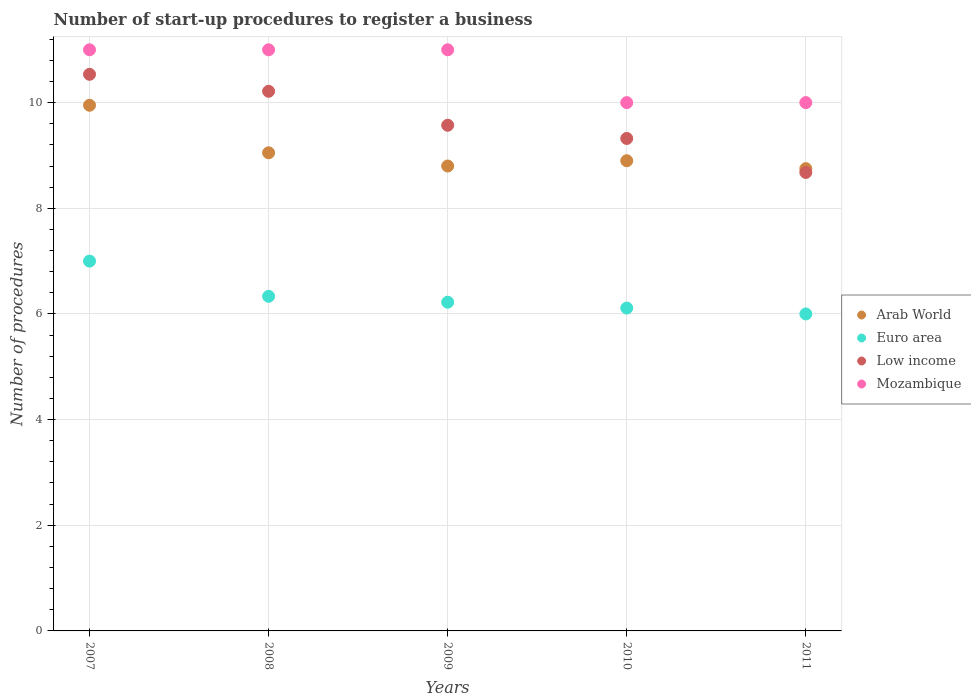How many different coloured dotlines are there?
Keep it short and to the point. 4. Is the number of dotlines equal to the number of legend labels?
Ensure brevity in your answer.  Yes. What is the number of procedures required to register a business in Arab World in 2010?
Make the answer very short. 8.9. Across all years, what is the maximum number of procedures required to register a business in Euro area?
Your response must be concise. 7. Across all years, what is the minimum number of procedures required to register a business in Mozambique?
Offer a terse response. 10. What is the total number of procedures required to register a business in Euro area in the graph?
Ensure brevity in your answer.  31.67. What is the difference between the number of procedures required to register a business in Low income in 2010 and that in 2011?
Keep it short and to the point. 0.64. What is the difference between the number of procedures required to register a business in Mozambique in 2011 and the number of procedures required to register a business in Low income in 2007?
Keep it short and to the point. -0.54. What is the average number of procedures required to register a business in Euro area per year?
Give a very brief answer. 6.33. In the year 2009, what is the difference between the number of procedures required to register a business in Arab World and number of procedures required to register a business in Low income?
Offer a terse response. -0.77. In how many years, is the number of procedures required to register a business in Low income greater than 10.4?
Your answer should be compact. 1. What is the ratio of the number of procedures required to register a business in Euro area in 2010 to that in 2011?
Ensure brevity in your answer.  1.02. What is the difference between the highest and the lowest number of procedures required to register a business in Mozambique?
Provide a short and direct response. 1. In how many years, is the number of procedures required to register a business in Euro area greater than the average number of procedures required to register a business in Euro area taken over all years?
Your answer should be very brief. 1. Is the sum of the number of procedures required to register a business in Euro area in 2007 and 2008 greater than the maximum number of procedures required to register a business in Arab World across all years?
Your answer should be very brief. Yes. Is it the case that in every year, the sum of the number of procedures required to register a business in Mozambique and number of procedures required to register a business in Low income  is greater than the number of procedures required to register a business in Euro area?
Keep it short and to the point. Yes. Is the number of procedures required to register a business in Arab World strictly greater than the number of procedures required to register a business in Euro area over the years?
Provide a succinct answer. Yes. How many dotlines are there?
Make the answer very short. 4. How many years are there in the graph?
Your answer should be compact. 5. Are the values on the major ticks of Y-axis written in scientific E-notation?
Provide a succinct answer. No. Does the graph contain any zero values?
Provide a succinct answer. No. Does the graph contain grids?
Keep it short and to the point. Yes. Where does the legend appear in the graph?
Make the answer very short. Center right. How many legend labels are there?
Provide a succinct answer. 4. What is the title of the graph?
Provide a short and direct response. Number of start-up procedures to register a business. What is the label or title of the Y-axis?
Your answer should be compact. Number of procedures. What is the Number of procedures in Arab World in 2007?
Offer a terse response. 9.95. What is the Number of procedures of Low income in 2007?
Offer a very short reply. 10.54. What is the Number of procedures of Arab World in 2008?
Make the answer very short. 9.05. What is the Number of procedures of Euro area in 2008?
Make the answer very short. 6.33. What is the Number of procedures of Low income in 2008?
Provide a short and direct response. 10.21. What is the Number of procedures of Mozambique in 2008?
Provide a short and direct response. 11. What is the Number of procedures of Arab World in 2009?
Provide a succinct answer. 8.8. What is the Number of procedures of Euro area in 2009?
Your answer should be compact. 6.22. What is the Number of procedures in Low income in 2009?
Provide a short and direct response. 9.57. What is the Number of procedures in Mozambique in 2009?
Make the answer very short. 11. What is the Number of procedures in Euro area in 2010?
Make the answer very short. 6.11. What is the Number of procedures in Low income in 2010?
Keep it short and to the point. 9.32. What is the Number of procedures in Mozambique in 2010?
Offer a terse response. 10. What is the Number of procedures in Arab World in 2011?
Offer a very short reply. 8.75. What is the Number of procedures in Euro area in 2011?
Your response must be concise. 6. What is the Number of procedures in Low income in 2011?
Your response must be concise. 8.68. What is the Number of procedures in Mozambique in 2011?
Your answer should be very brief. 10. Across all years, what is the maximum Number of procedures of Arab World?
Offer a very short reply. 9.95. Across all years, what is the maximum Number of procedures in Euro area?
Offer a very short reply. 7. Across all years, what is the maximum Number of procedures of Low income?
Your response must be concise. 10.54. Across all years, what is the maximum Number of procedures of Mozambique?
Make the answer very short. 11. Across all years, what is the minimum Number of procedures in Arab World?
Provide a short and direct response. 8.75. Across all years, what is the minimum Number of procedures of Euro area?
Give a very brief answer. 6. Across all years, what is the minimum Number of procedures of Low income?
Keep it short and to the point. 8.68. Across all years, what is the minimum Number of procedures of Mozambique?
Provide a succinct answer. 10. What is the total Number of procedures of Arab World in the graph?
Make the answer very short. 45.45. What is the total Number of procedures of Euro area in the graph?
Ensure brevity in your answer.  31.67. What is the total Number of procedures in Low income in the graph?
Keep it short and to the point. 48.32. What is the total Number of procedures of Mozambique in the graph?
Provide a succinct answer. 53. What is the difference between the Number of procedures of Low income in 2007 and that in 2008?
Ensure brevity in your answer.  0.32. What is the difference between the Number of procedures in Mozambique in 2007 and that in 2008?
Make the answer very short. 0. What is the difference between the Number of procedures in Arab World in 2007 and that in 2009?
Your answer should be very brief. 1.15. What is the difference between the Number of procedures in Euro area in 2007 and that in 2009?
Ensure brevity in your answer.  0.78. What is the difference between the Number of procedures of Mozambique in 2007 and that in 2009?
Make the answer very short. 0. What is the difference between the Number of procedures of Low income in 2007 and that in 2010?
Offer a terse response. 1.21. What is the difference between the Number of procedures in Arab World in 2007 and that in 2011?
Give a very brief answer. 1.2. What is the difference between the Number of procedures in Euro area in 2007 and that in 2011?
Your response must be concise. 1. What is the difference between the Number of procedures of Low income in 2007 and that in 2011?
Ensure brevity in your answer.  1.86. What is the difference between the Number of procedures of Mozambique in 2007 and that in 2011?
Your answer should be compact. 1. What is the difference between the Number of procedures in Arab World in 2008 and that in 2009?
Offer a very short reply. 0.25. What is the difference between the Number of procedures of Euro area in 2008 and that in 2009?
Provide a succinct answer. 0.11. What is the difference between the Number of procedures of Low income in 2008 and that in 2009?
Ensure brevity in your answer.  0.64. What is the difference between the Number of procedures in Euro area in 2008 and that in 2010?
Offer a very short reply. 0.22. What is the difference between the Number of procedures of Low income in 2008 and that in 2010?
Provide a short and direct response. 0.89. What is the difference between the Number of procedures of Mozambique in 2008 and that in 2010?
Your response must be concise. 1. What is the difference between the Number of procedures of Euro area in 2008 and that in 2011?
Offer a very short reply. 0.33. What is the difference between the Number of procedures of Low income in 2008 and that in 2011?
Provide a short and direct response. 1.54. What is the difference between the Number of procedures in Mozambique in 2008 and that in 2011?
Your answer should be very brief. 1. What is the difference between the Number of procedures of Arab World in 2009 and that in 2010?
Your answer should be very brief. -0.1. What is the difference between the Number of procedures of Euro area in 2009 and that in 2010?
Ensure brevity in your answer.  0.11. What is the difference between the Number of procedures in Euro area in 2009 and that in 2011?
Provide a short and direct response. 0.22. What is the difference between the Number of procedures in Low income in 2009 and that in 2011?
Your response must be concise. 0.89. What is the difference between the Number of procedures in Mozambique in 2009 and that in 2011?
Ensure brevity in your answer.  1. What is the difference between the Number of procedures of Arab World in 2010 and that in 2011?
Make the answer very short. 0.15. What is the difference between the Number of procedures of Euro area in 2010 and that in 2011?
Provide a short and direct response. 0.11. What is the difference between the Number of procedures in Low income in 2010 and that in 2011?
Your answer should be compact. 0.64. What is the difference between the Number of procedures in Mozambique in 2010 and that in 2011?
Offer a very short reply. 0. What is the difference between the Number of procedures in Arab World in 2007 and the Number of procedures in Euro area in 2008?
Your response must be concise. 3.62. What is the difference between the Number of procedures of Arab World in 2007 and the Number of procedures of Low income in 2008?
Keep it short and to the point. -0.26. What is the difference between the Number of procedures in Arab World in 2007 and the Number of procedures in Mozambique in 2008?
Your answer should be compact. -1.05. What is the difference between the Number of procedures in Euro area in 2007 and the Number of procedures in Low income in 2008?
Keep it short and to the point. -3.21. What is the difference between the Number of procedures of Low income in 2007 and the Number of procedures of Mozambique in 2008?
Make the answer very short. -0.46. What is the difference between the Number of procedures of Arab World in 2007 and the Number of procedures of Euro area in 2009?
Offer a very short reply. 3.73. What is the difference between the Number of procedures of Arab World in 2007 and the Number of procedures of Low income in 2009?
Your response must be concise. 0.38. What is the difference between the Number of procedures of Arab World in 2007 and the Number of procedures of Mozambique in 2009?
Offer a terse response. -1.05. What is the difference between the Number of procedures in Euro area in 2007 and the Number of procedures in Low income in 2009?
Offer a terse response. -2.57. What is the difference between the Number of procedures of Low income in 2007 and the Number of procedures of Mozambique in 2009?
Provide a succinct answer. -0.46. What is the difference between the Number of procedures of Arab World in 2007 and the Number of procedures of Euro area in 2010?
Your answer should be compact. 3.84. What is the difference between the Number of procedures in Arab World in 2007 and the Number of procedures in Low income in 2010?
Offer a very short reply. 0.63. What is the difference between the Number of procedures of Arab World in 2007 and the Number of procedures of Mozambique in 2010?
Your response must be concise. -0.05. What is the difference between the Number of procedures in Euro area in 2007 and the Number of procedures in Low income in 2010?
Offer a terse response. -2.32. What is the difference between the Number of procedures in Low income in 2007 and the Number of procedures in Mozambique in 2010?
Your answer should be compact. 0.54. What is the difference between the Number of procedures of Arab World in 2007 and the Number of procedures of Euro area in 2011?
Ensure brevity in your answer.  3.95. What is the difference between the Number of procedures in Arab World in 2007 and the Number of procedures in Low income in 2011?
Offer a terse response. 1.27. What is the difference between the Number of procedures of Arab World in 2007 and the Number of procedures of Mozambique in 2011?
Your answer should be very brief. -0.05. What is the difference between the Number of procedures in Euro area in 2007 and the Number of procedures in Low income in 2011?
Keep it short and to the point. -1.68. What is the difference between the Number of procedures in Low income in 2007 and the Number of procedures in Mozambique in 2011?
Provide a succinct answer. 0.54. What is the difference between the Number of procedures of Arab World in 2008 and the Number of procedures of Euro area in 2009?
Offer a very short reply. 2.83. What is the difference between the Number of procedures in Arab World in 2008 and the Number of procedures in Low income in 2009?
Provide a succinct answer. -0.52. What is the difference between the Number of procedures of Arab World in 2008 and the Number of procedures of Mozambique in 2009?
Give a very brief answer. -1.95. What is the difference between the Number of procedures of Euro area in 2008 and the Number of procedures of Low income in 2009?
Make the answer very short. -3.24. What is the difference between the Number of procedures of Euro area in 2008 and the Number of procedures of Mozambique in 2009?
Your response must be concise. -4.67. What is the difference between the Number of procedures in Low income in 2008 and the Number of procedures in Mozambique in 2009?
Keep it short and to the point. -0.79. What is the difference between the Number of procedures of Arab World in 2008 and the Number of procedures of Euro area in 2010?
Provide a short and direct response. 2.94. What is the difference between the Number of procedures in Arab World in 2008 and the Number of procedures in Low income in 2010?
Give a very brief answer. -0.27. What is the difference between the Number of procedures of Arab World in 2008 and the Number of procedures of Mozambique in 2010?
Provide a succinct answer. -0.95. What is the difference between the Number of procedures of Euro area in 2008 and the Number of procedures of Low income in 2010?
Your response must be concise. -2.99. What is the difference between the Number of procedures in Euro area in 2008 and the Number of procedures in Mozambique in 2010?
Offer a terse response. -3.67. What is the difference between the Number of procedures of Low income in 2008 and the Number of procedures of Mozambique in 2010?
Provide a short and direct response. 0.21. What is the difference between the Number of procedures of Arab World in 2008 and the Number of procedures of Euro area in 2011?
Keep it short and to the point. 3.05. What is the difference between the Number of procedures in Arab World in 2008 and the Number of procedures in Low income in 2011?
Provide a short and direct response. 0.37. What is the difference between the Number of procedures of Arab World in 2008 and the Number of procedures of Mozambique in 2011?
Provide a succinct answer. -0.95. What is the difference between the Number of procedures of Euro area in 2008 and the Number of procedures of Low income in 2011?
Your answer should be compact. -2.35. What is the difference between the Number of procedures in Euro area in 2008 and the Number of procedures in Mozambique in 2011?
Provide a short and direct response. -3.67. What is the difference between the Number of procedures of Low income in 2008 and the Number of procedures of Mozambique in 2011?
Your response must be concise. 0.21. What is the difference between the Number of procedures in Arab World in 2009 and the Number of procedures in Euro area in 2010?
Keep it short and to the point. 2.69. What is the difference between the Number of procedures of Arab World in 2009 and the Number of procedures of Low income in 2010?
Your answer should be compact. -0.52. What is the difference between the Number of procedures of Arab World in 2009 and the Number of procedures of Mozambique in 2010?
Your answer should be compact. -1.2. What is the difference between the Number of procedures of Euro area in 2009 and the Number of procedures of Low income in 2010?
Your answer should be very brief. -3.1. What is the difference between the Number of procedures of Euro area in 2009 and the Number of procedures of Mozambique in 2010?
Give a very brief answer. -3.78. What is the difference between the Number of procedures in Low income in 2009 and the Number of procedures in Mozambique in 2010?
Keep it short and to the point. -0.43. What is the difference between the Number of procedures in Arab World in 2009 and the Number of procedures in Low income in 2011?
Provide a succinct answer. 0.12. What is the difference between the Number of procedures in Euro area in 2009 and the Number of procedures in Low income in 2011?
Provide a short and direct response. -2.46. What is the difference between the Number of procedures of Euro area in 2009 and the Number of procedures of Mozambique in 2011?
Provide a succinct answer. -3.78. What is the difference between the Number of procedures in Low income in 2009 and the Number of procedures in Mozambique in 2011?
Provide a short and direct response. -0.43. What is the difference between the Number of procedures in Arab World in 2010 and the Number of procedures in Low income in 2011?
Your answer should be very brief. 0.22. What is the difference between the Number of procedures in Arab World in 2010 and the Number of procedures in Mozambique in 2011?
Give a very brief answer. -1.1. What is the difference between the Number of procedures of Euro area in 2010 and the Number of procedures of Low income in 2011?
Give a very brief answer. -2.57. What is the difference between the Number of procedures of Euro area in 2010 and the Number of procedures of Mozambique in 2011?
Give a very brief answer. -3.89. What is the difference between the Number of procedures in Low income in 2010 and the Number of procedures in Mozambique in 2011?
Your response must be concise. -0.68. What is the average Number of procedures of Arab World per year?
Your answer should be compact. 9.09. What is the average Number of procedures of Euro area per year?
Ensure brevity in your answer.  6.33. What is the average Number of procedures in Low income per year?
Your answer should be very brief. 9.66. In the year 2007, what is the difference between the Number of procedures of Arab World and Number of procedures of Euro area?
Offer a very short reply. 2.95. In the year 2007, what is the difference between the Number of procedures of Arab World and Number of procedures of Low income?
Offer a terse response. -0.59. In the year 2007, what is the difference between the Number of procedures in Arab World and Number of procedures in Mozambique?
Your response must be concise. -1.05. In the year 2007, what is the difference between the Number of procedures of Euro area and Number of procedures of Low income?
Offer a terse response. -3.54. In the year 2007, what is the difference between the Number of procedures of Euro area and Number of procedures of Mozambique?
Your response must be concise. -4. In the year 2007, what is the difference between the Number of procedures in Low income and Number of procedures in Mozambique?
Provide a succinct answer. -0.46. In the year 2008, what is the difference between the Number of procedures in Arab World and Number of procedures in Euro area?
Ensure brevity in your answer.  2.72. In the year 2008, what is the difference between the Number of procedures in Arab World and Number of procedures in Low income?
Make the answer very short. -1.16. In the year 2008, what is the difference between the Number of procedures in Arab World and Number of procedures in Mozambique?
Ensure brevity in your answer.  -1.95. In the year 2008, what is the difference between the Number of procedures in Euro area and Number of procedures in Low income?
Make the answer very short. -3.88. In the year 2008, what is the difference between the Number of procedures in Euro area and Number of procedures in Mozambique?
Keep it short and to the point. -4.67. In the year 2008, what is the difference between the Number of procedures in Low income and Number of procedures in Mozambique?
Offer a terse response. -0.79. In the year 2009, what is the difference between the Number of procedures of Arab World and Number of procedures of Euro area?
Give a very brief answer. 2.58. In the year 2009, what is the difference between the Number of procedures in Arab World and Number of procedures in Low income?
Offer a very short reply. -0.77. In the year 2009, what is the difference between the Number of procedures in Arab World and Number of procedures in Mozambique?
Ensure brevity in your answer.  -2.2. In the year 2009, what is the difference between the Number of procedures in Euro area and Number of procedures in Low income?
Make the answer very short. -3.35. In the year 2009, what is the difference between the Number of procedures of Euro area and Number of procedures of Mozambique?
Provide a succinct answer. -4.78. In the year 2009, what is the difference between the Number of procedures in Low income and Number of procedures in Mozambique?
Your answer should be compact. -1.43. In the year 2010, what is the difference between the Number of procedures of Arab World and Number of procedures of Euro area?
Give a very brief answer. 2.79. In the year 2010, what is the difference between the Number of procedures of Arab World and Number of procedures of Low income?
Make the answer very short. -0.42. In the year 2010, what is the difference between the Number of procedures of Euro area and Number of procedures of Low income?
Your answer should be very brief. -3.21. In the year 2010, what is the difference between the Number of procedures of Euro area and Number of procedures of Mozambique?
Your answer should be compact. -3.89. In the year 2010, what is the difference between the Number of procedures of Low income and Number of procedures of Mozambique?
Offer a terse response. -0.68. In the year 2011, what is the difference between the Number of procedures of Arab World and Number of procedures of Euro area?
Your response must be concise. 2.75. In the year 2011, what is the difference between the Number of procedures in Arab World and Number of procedures in Low income?
Provide a short and direct response. 0.07. In the year 2011, what is the difference between the Number of procedures of Arab World and Number of procedures of Mozambique?
Give a very brief answer. -1.25. In the year 2011, what is the difference between the Number of procedures in Euro area and Number of procedures in Low income?
Give a very brief answer. -2.68. In the year 2011, what is the difference between the Number of procedures in Low income and Number of procedures in Mozambique?
Offer a very short reply. -1.32. What is the ratio of the Number of procedures of Arab World in 2007 to that in 2008?
Ensure brevity in your answer.  1.1. What is the ratio of the Number of procedures of Euro area in 2007 to that in 2008?
Offer a terse response. 1.11. What is the ratio of the Number of procedures of Low income in 2007 to that in 2008?
Ensure brevity in your answer.  1.03. What is the ratio of the Number of procedures in Arab World in 2007 to that in 2009?
Make the answer very short. 1.13. What is the ratio of the Number of procedures of Euro area in 2007 to that in 2009?
Ensure brevity in your answer.  1.12. What is the ratio of the Number of procedures of Low income in 2007 to that in 2009?
Your answer should be very brief. 1.1. What is the ratio of the Number of procedures of Arab World in 2007 to that in 2010?
Your answer should be very brief. 1.12. What is the ratio of the Number of procedures of Euro area in 2007 to that in 2010?
Your answer should be very brief. 1.15. What is the ratio of the Number of procedures of Low income in 2007 to that in 2010?
Your response must be concise. 1.13. What is the ratio of the Number of procedures in Arab World in 2007 to that in 2011?
Your response must be concise. 1.14. What is the ratio of the Number of procedures in Euro area in 2007 to that in 2011?
Your response must be concise. 1.17. What is the ratio of the Number of procedures in Low income in 2007 to that in 2011?
Give a very brief answer. 1.21. What is the ratio of the Number of procedures of Mozambique in 2007 to that in 2011?
Provide a succinct answer. 1.1. What is the ratio of the Number of procedures of Arab World in 2008 to that in 2009?
Provide a short and direct response. 1.03. What is the ratio of the Number of procedures in Euro area in 2008 to that in 2009?
Offer a very short reply. 1.02. What is the ratio of the Number of procedures of Low income in 2008 to that in 2009?
Your answer should be compact. 1.07. What is the ratio of the Number of procedures in Arab World in 2008 to that in 2010?
Make the answer very short. 1.02. What is the ratio of the Number of procedures in Euro area in 2008 to that in 2010?
Ensure brevity in your answer.  1.04. What is the ratio of the Number of procedures in Low income in 2008 to that in 2010?
Offer a very short reply. 1.1. What is the ratio of the Number of procedures in Arab World in 2008 to that in 2011?
Offer a very short reply. 1.03. What is the ratio of the Number of procedures of Euro area in 2008 to that in 2011?
Offer a very short reply. 1.06. What is the ratio of the Number of procedures of Low income in 2008 to that in 2011?
Your response must be concise. 1.18. What is the ratio of the Number of procedures of Euro area in 2009 to that in 2010?
Keep it short and to the point. 1.02. What is the ratio of the Number of procedures of Low income in 2009 to that in 2010?
Make the answer very short. 1.03. What is the ratio of the Number of procedures of Arab World in 2009 to that in 2011?
Your answer should be very brief. 1.01. What is the ratio of the Number of procedures of Low income in 2009 to that in 2011?
Your answer should be compact. 1.1. What is the ratio of the Number of procedures of Mozambique in 2009 to that in 2011?
Ensure brevity in your answer.  1.1. What is the ratio of the Number of procedures of Arab World in 2010 to that in 2011?
Your answer should be compact. 1.02. What is the ratio of the Number of procedures in Euro area in 2010 to that in 2011?
Provide a succinct answer. 1.02. What is the ratio of the Number of procedures of Low income in 2010 to that in 2011?
Offer a very short reply. 1.07. What is the difference between the highest and the second highest Number of procedures of Low income?
Give a very brief answer. 0.32. What is the difference between the highest and the lowest Number of procedures in Arab World?
Your response must be concise. 1.2. What is the difference between the highest and the lowest Number of procedures of Euro area?
Offer a terse response. 1. What is the difference between the highest and the lowest Number of procedures of Low income?
Your response must be concise. 1.86. What is the difference between the highest and the lowest Number of procedures in Mozambique?
Provide a short and direct response. 1. 